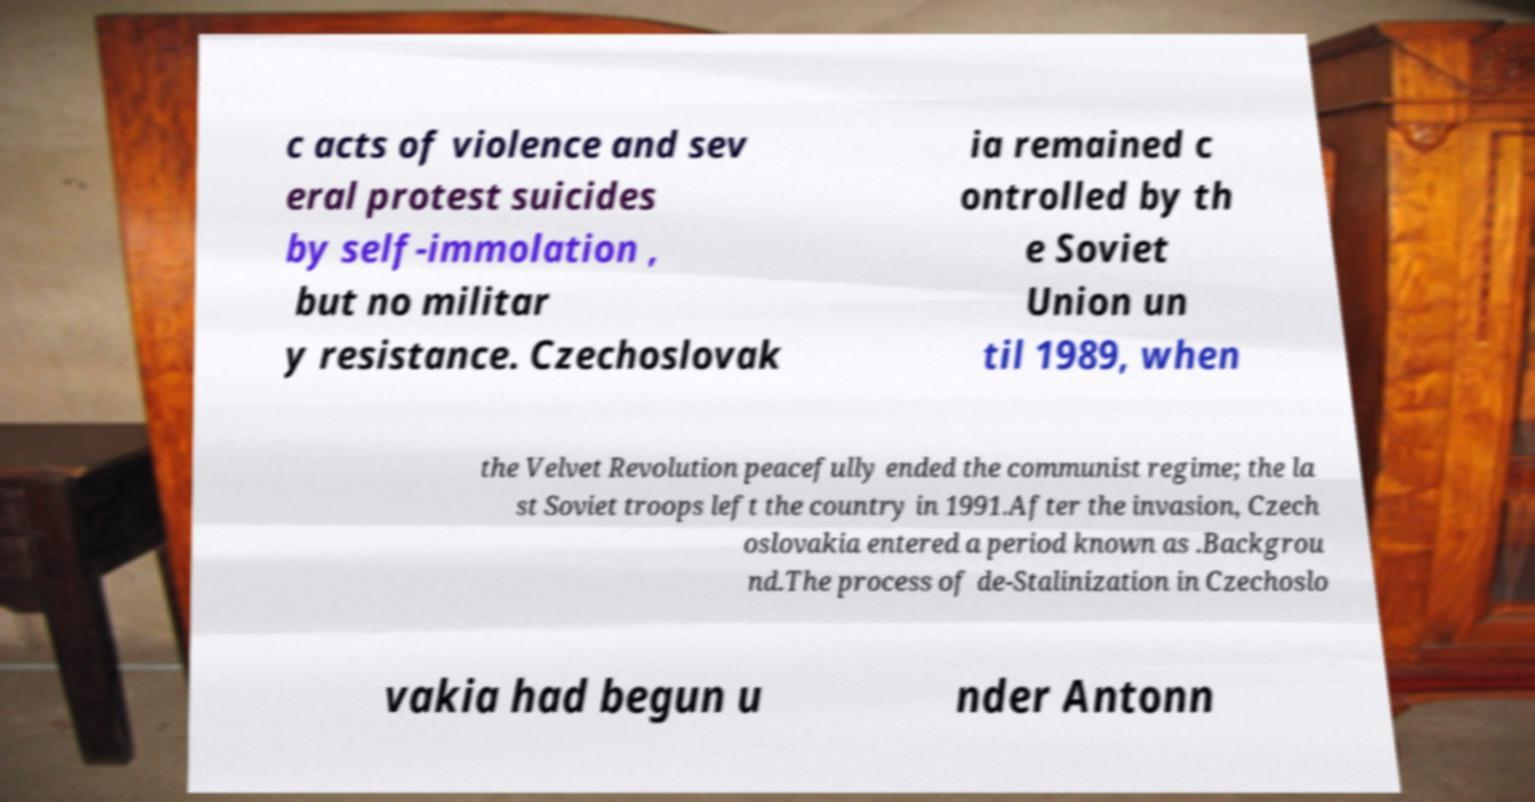Can you accurately transcribe the text from the provided image for me? c acts of violence and sev eral protest suicides by self-immolation , but no militar y resistance. Czechoslovak ia remained c ontrolled by th e Soviet Union un til 1989, when the Velvet Revolution peacefully ended the communist regime; the la st Soviet troops left the country in 1991.After the invasion, Czech oslovakia entered a period known as .Backgrou nd.The process of de-Stalinization in Czechoslo vakia had begun u nder Antonn 